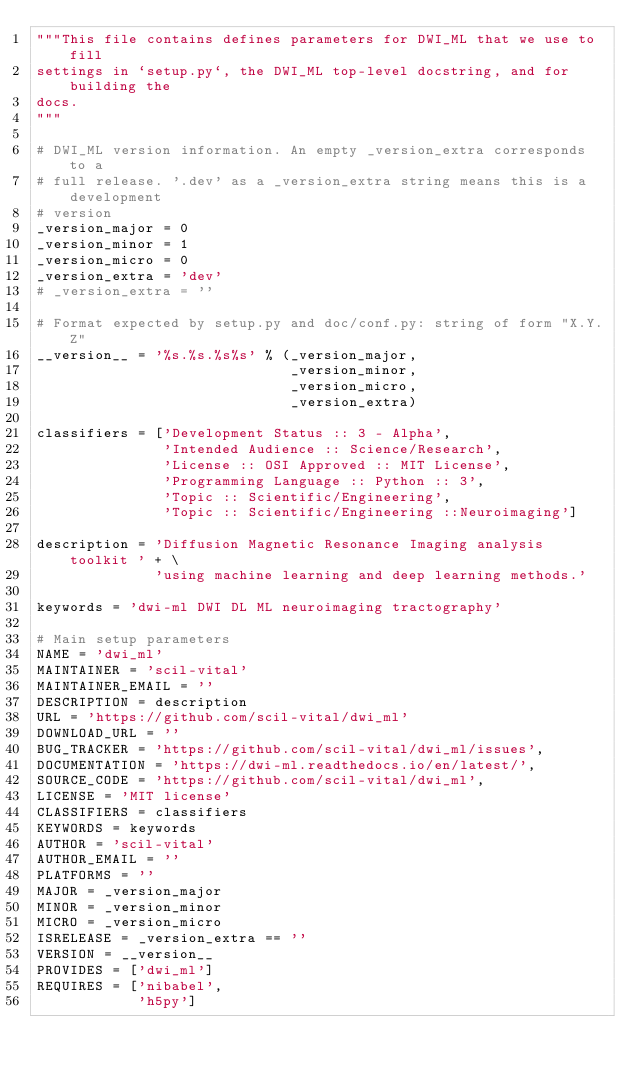Convert code to text. <code><loc_0><loc_0><loc_500><loc_500><_Python_>"""This file contains defines parameters for DWI_ML that we use to fill
settings in `setup.py`, the DWI_ML top-level docstring, and for building the
docs.
"""

# DWI_ML version information. An empty _version_extra corresponds to a
# full release. '.dev' as a _version_extra string means this is a development
# version
_version_major = 0
_version_minor = 1
_version_micro = 0
_version_extra = 'dev'
# _version_extra = ''

# Format expected by setup.py and doc/conf.py: string of form "X.Y.Z"
__version__ = '%s.%s.%s%s' % (_version_major,
                              _version_minor,
                              _version_micro,
                              _version_extra)

classifiers = ['Development Status :: 3 - Alpha',
               'Intended Audience :: Science/Research',
               'License :: OSI Approved :: MIT License',
               'Programming Language :: Python :: 3',
               'Topic :: Scientific/Engineering',
               'Topic :: Scientific/Engineering ::Neuroimaging']

description = 'Diffusion Magnetic Resonance Imaging analysis toolkit ' + \
              'using machine learning and deep learning methods.'

keywords = 'dwi-ml DWI DL ML neuroimaging tractography'

# Main setup parameters
NAME = 'dwi_ml'
MAINTAINER = 'scil-vital'
MAINTAINER_EMAIL = ''
DESCRIPTION = description
URL = 'https://github.com/scil-vital/dwi_ml'
DOWNLOAD_URL = ''
BUG_TRACKER = 'https://github.com/scil-vital/dwi_ml/issues',
DOCUMENTATION = 'https://dwi-ml.readthedocs.io/en/latest/',
SOURCE_CODE = 'https://github.com/scil-vital/dwi_ml',
LICENSE = 'MIT license'
CLASSIFIERS = classifiers
KEYWORDS = keywords
AUTHOR = 'scil-vital'
AUTHOR_EMAIL = ''
PLATFORMS = ''
MAJOR = _version_major
MINOR = _version_minor
MICRO = _version_micro
ISRELEASE = _version_extra == ''
VERSION = __version__
PROVIDES = ['dwi_ml']
REQUIRES = ['nibabel',
            'h5py']
</code> 